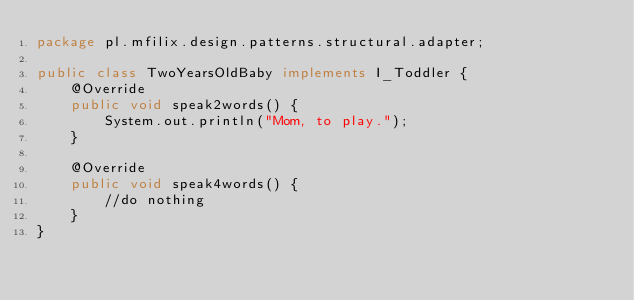<code> <loc_0><loc_0><loc_500><loc_500><_Java_>package pl.mfilix.design.patterns.structural.adapter;

public class TwoYearsOldBaby implements I_Toddler {
    @Override
    public void speak2words() {
        System.out.println("Mom, to play.");
    }

    @Override
    public void speak4words() {
        //do nothing
    }
}
</code> 